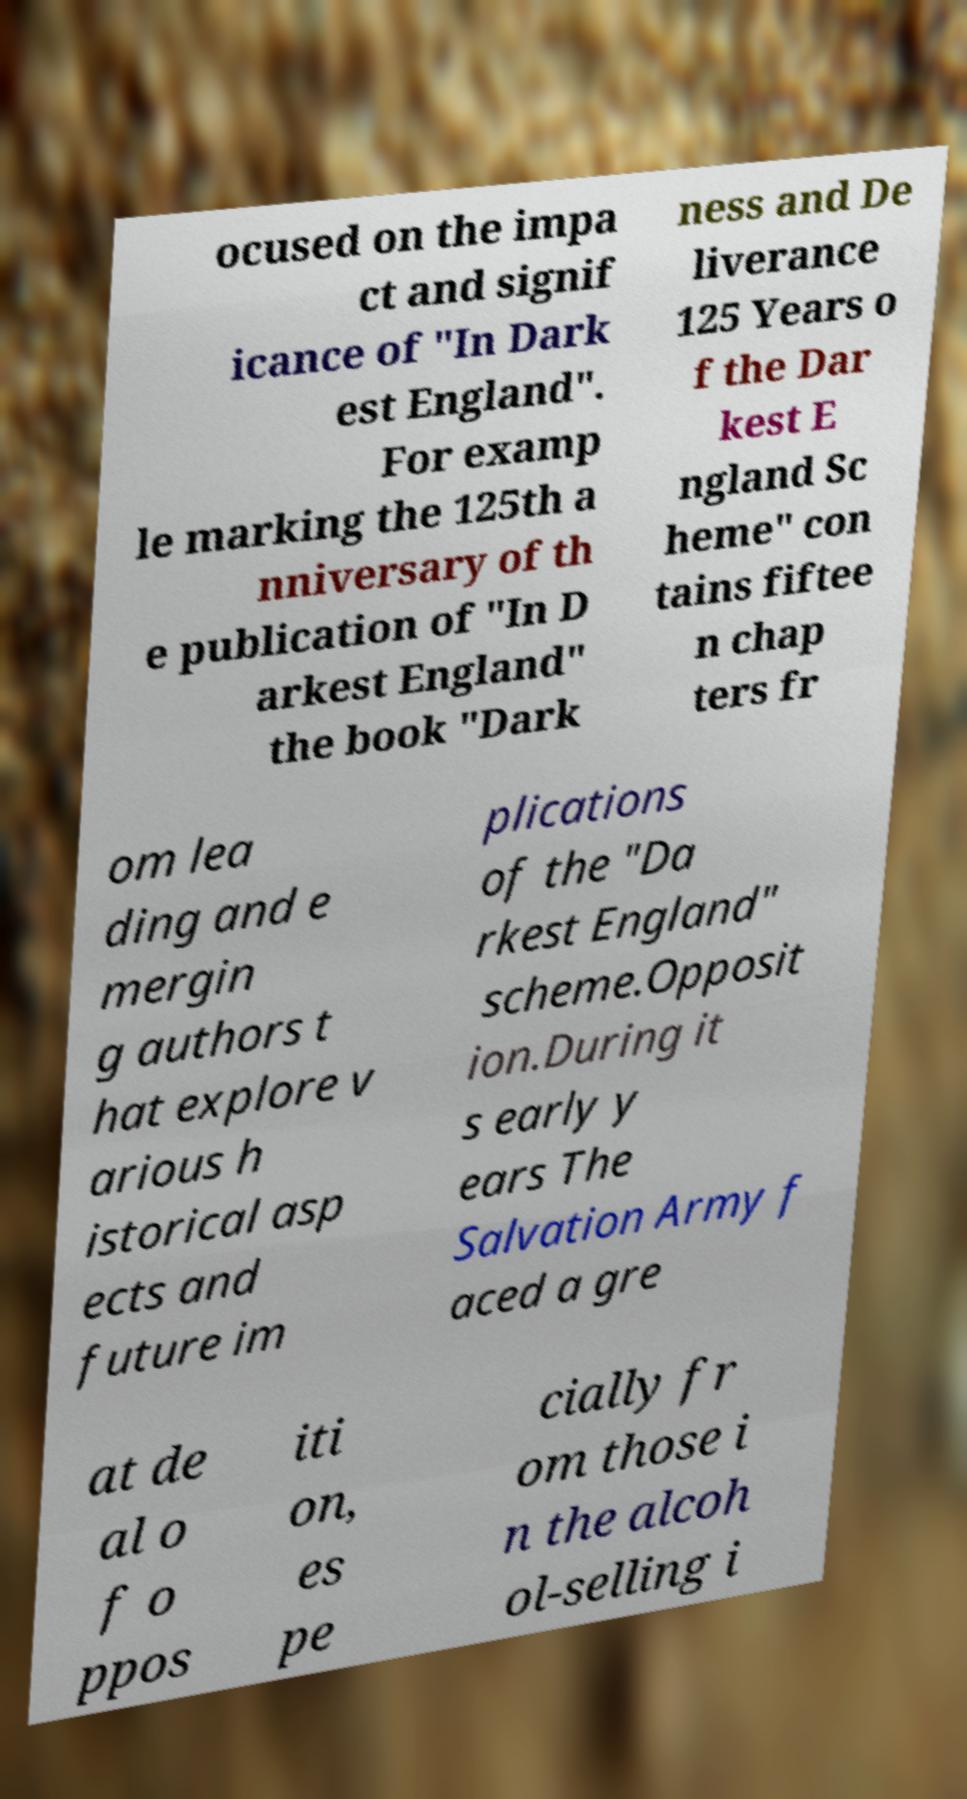I need the written content from this picture converted into text. Can you do that? ocused on the impa ct and signif icance of "In Dark est England". For examp le marking the 125th a nniversary of th e publication of "In D arkest England" the book "Dark ness and De liverance 125 Years o f the Dar kest E ngland Sc heme" con tains fiftee n chap ters fr om lea ding and e mergin g authors t hat explore v arious h istorical asp ects and future im plications of the "Da rkest England" scheme.Opposit ion.During it s early y ears The Salvation Army f aced a gre at de al o f o ppos iti on, es pe cially fr om those i n the alcoh ol-selling i 